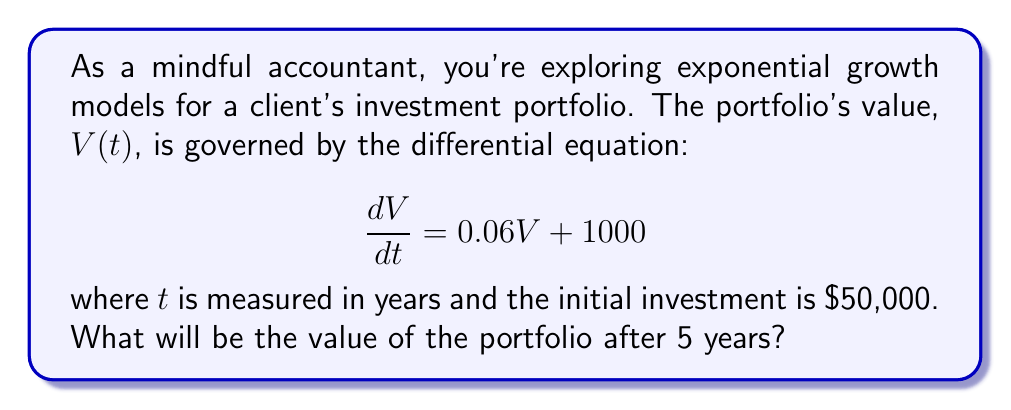Can you solve this math problem? Let's approach this step-by-step:

1) The given differential equation is of the form:
   $$\frac{dV}{dt} = aV + b$$
   where $a = 0.06$ and $b = 1000$.

2) The general solution for this type of equation is:
   $$V(t) = Ce^{at} - \frac{b}{a}$$
   where $C$ is a constant we need to determine.

3) Substituting our values:
   $$V(t) = Ce^{0.06t} - \frac{1000}{0.06}$$

4) To find $C$, we use the initial condition. At $t=0$, $V(0) = 50000$:
   $$50000 = C - \frac{1000}{0.06}$$
   $$C = 50000 + \frac{1000}{0.06} = 50000 + 16666.67 = 66666.67$$

5) Now our specific solution is:
   $$V(t) = 66666.67e^{0.06t} - 16666.67$$

6) To find the value after 5 years, we calculate $V(5)$:
   $$V(5) = 66666.67e^{0.06(5)} - 16666.67$$
   $$= 66666.67e^{0.3} - 16666.67$$
   $$= 66666.67(1.34986) - 16666.67$$
   $$= 89991.13 - 16666.67$$
   $$= 73324.46$$

Therefore, after 5 years, the portfolio value will be approximately $\$73,324.46$.
Answer: $73,324.46 